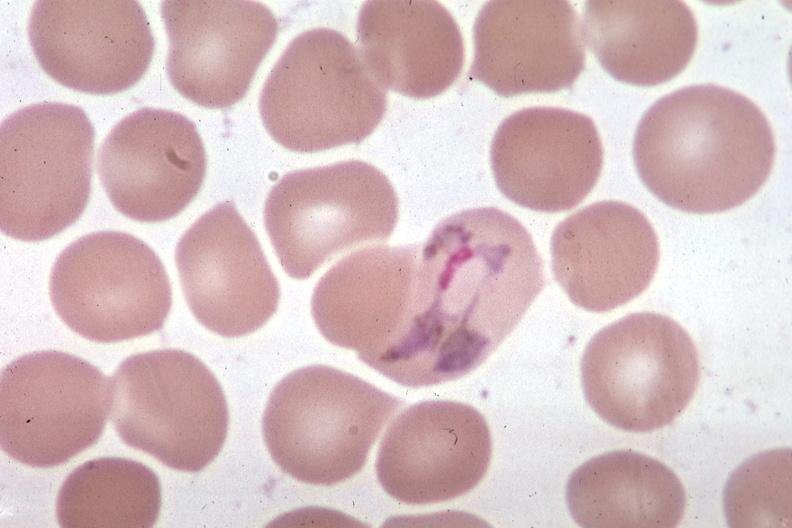does subcapsular hematoma show wrights excellent?
Answer the question using a single word or phrase. No 